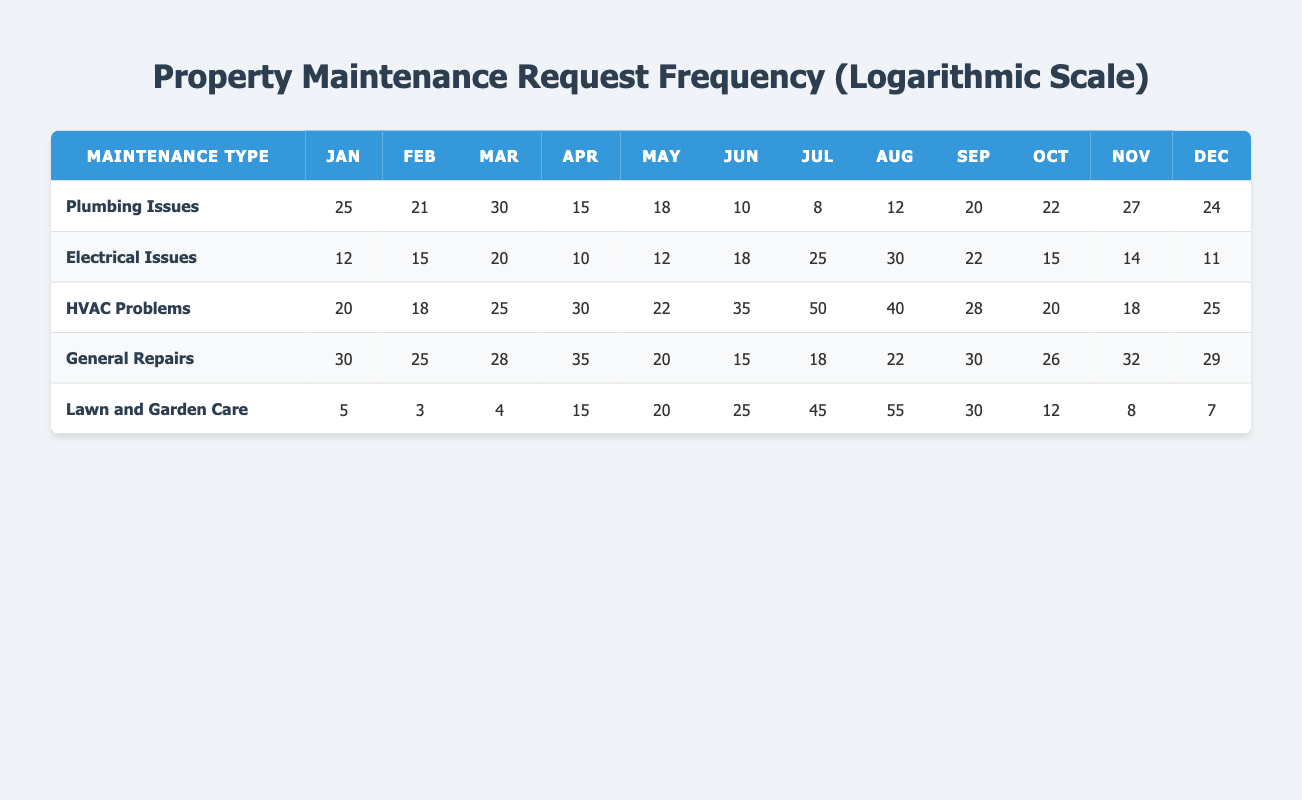What is the total number of plumbing issues reported in July? From the table, the number of plumbing issues in July is listed as 8.
Answer: 8 Which month had the highest reports of HVAC problems? Looking at the monthly data for HVAC problems, July has the highest count at 50.
Answer: July What is the average number of electrical issues across all months? To find the average, we sum the monthly values (12 + 15 + 20 + 10 + 12 + 18 + 25 + 30 + 22 + 15 + 14 + 11 =  12 + 15 + 20 + 10 + 12 + 18 + 25 + 30 + 22 + 15 + 14 + 11 = 23) and divide by 12 months:  268/12 ≈ 22.33.
Answer: 22.33 Did the number of lawn and garden care requests increase from May to July? In May, there were 20 requests, and in July, there were 45 requests. Since 45 is greater than 20, it did increase.
Answer: Yes What is the total number of general repairs made from March to June? The monthly data for general repairs shows: March (28) + April (35) + May (20) + June (15) = 28 + 35 + 20 + 15 = 98.
Answer: 98 What is the difference in the number of plumbing issues between January and April? Plumbing issues for January is 25 and for April is 15. The difference is 25 - 15 = 10.
Answer: 10 Is it true that there were more electrical issues reported in August than in June? There were 30 electrical issues reported in August and 18 in June, thus 30 > 18, confirming the statement is true.
Answer: True Which type of maintenance request had the largest total count throughout the year? Calculating the total for each type: Plumbing issues (25 + 21 + 30 + 15 + 18 + 10 + 8 + 12 + 20 + 22 + 27 + 24 =  242); Electrical issues = 12 + 15 + 20 + 10 + 12 + 18 + 25 + 30 + 22 + 15 + 14 + 11 =  249; HVAC problems = 20 + 18 + 25 + 30 + 22 + 35 + 50 + 40 + 28 + 20 + 18 + 25 =  319; General repairs = 30 + 25 + 28 + 35 + 20 + 15 + 18 + 22 + 30 + 26 + 32 + 29 =  359; Lawn and garden = 5 + 3 + 4 + 15 + 20 + 25 + 45 + 55 + 30 + 12 + 8 + 7 =  234. The highest total is for General repairs at 359.
Answer: General repairs What is the median number of HVAC problems across the months of the year? The monthly data for HVAC problems is: [20, 18, 25, 30, 22, 35, 50, 40, 28, 20, 18, 25]. Ordering these values gives us: [18, 18, 20, 20, 22, 25, 25, 28, 30, 35, 40, 50]. The median is the average of the 6th and 7th values: (25 + 25) / 2 = 25.
Answer: 25 